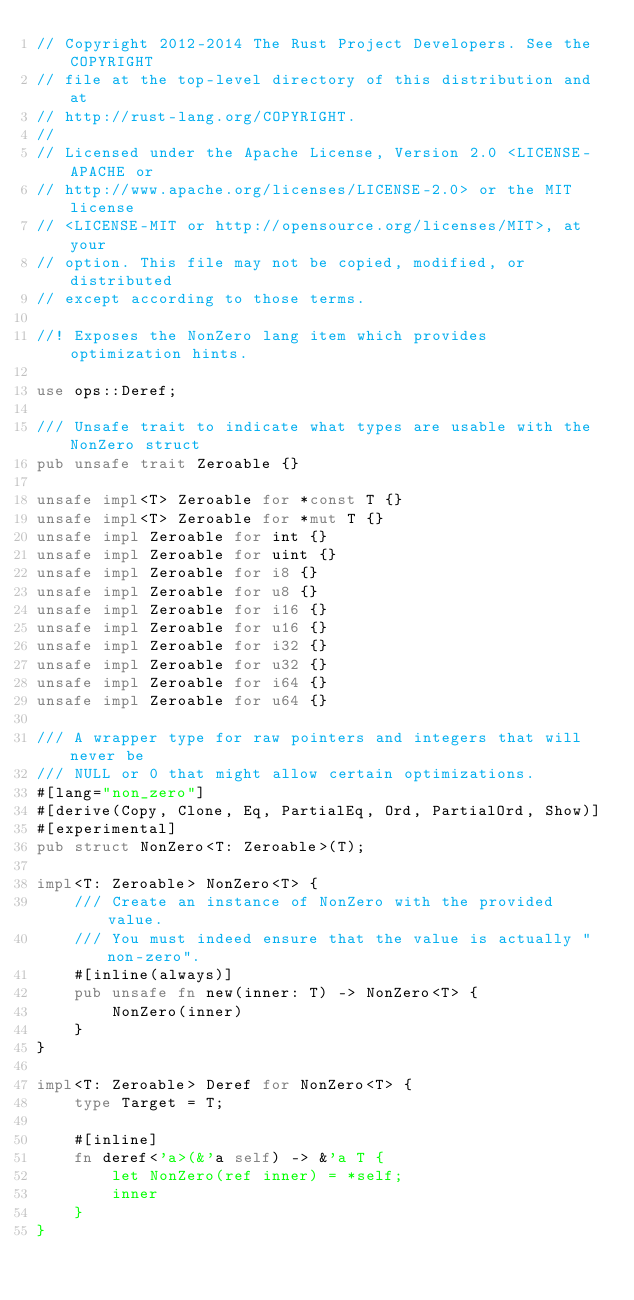Convert code to text. <code><loc_0><loc_0><loc_500><loc_500><_Rust_>// Copyright 2012-2014 The Rust Project Developers. See the COPYRIGHT
// file at the top-level directory of this distribution and at
// http://rust-lang.org/COPYRIGHT.
//
// Licensed under the Apache License, Version 2.0 <LICENSE-APACHE or
// http://www.apache.org/licenses/LICENSE-2.0> or the MIT license
// <LICENSE-MIT or http://opensource.org/licenses/MIT>, at your
// option. This file may not be copied, modified, or distributed
// except according to those terms.

//! Exposes the NonZero lang item which provides optimization hints.

use ops::Deref;

/// Unsafe trait to indicate what types are usable with the NonZero struct
pub unsafe trait Zeroable {}

unsafe impl<T> Zeroable for *const T {}
unsafe impl<T> Zeroable for *mut T {}
unsafe impl Zeroable for int {}
unsafe impl Zeroable for uint {}
unsafe impl Zeroable for i8 {}
unsafe impl Zeroable for u8 {}
unsafe impl Zeroable for i16 {}
unsafe impl Zeroable for u16 {}
unsafe impl Zeroable for i32 {}
unsafe impl Zeroable for u32 {}
unsafe impl Zeroable for i64 {}
unsafe impl Zeroable for u64 {}

/// A wrapper type for raw pointers and integers that will never be
/// NULL or 0 that might allow certain optimizations.
#[lang="non_zero"]
#[derive(Copy, Clone, Eq, PartialEq, Ord, PartialOrd, Show)]
#[experimental]
pub struct NonZero<T: Zeroable>(T);

impl<T: Zeroable> NonZero<T> {
    /// Create an instance of NonZero with the provided value.
    /// You must indeed ensure that the value is actually "non-zero".
    #[inline(always)]
    pub unsafe fn new(inner: T) -> NonZero<T> {
        NonZero(inner)
    }
}

impl<T: Zeroable> Deref for NonZero<T> {
    type Target = T;

    #[inline]
    fn deref<'a>(&'a self) -> &'a T {
        let NonZero(ref inner) = *self;
        inner
    }
}
</code> 